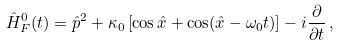<formula> <loc_0><loc_0><loc_500><loc_500>\hat { H } ^ { 0 } _ { F } ( t ) = \hat { p } ^ { 2 } + \kappa _ { 0 } \left [ \cos \hat { x } + \cos ( \hat { x } - \omega _ { 0 } t ) \right ] - i \frac { \partial } { \partial t } \, ,</formula> 